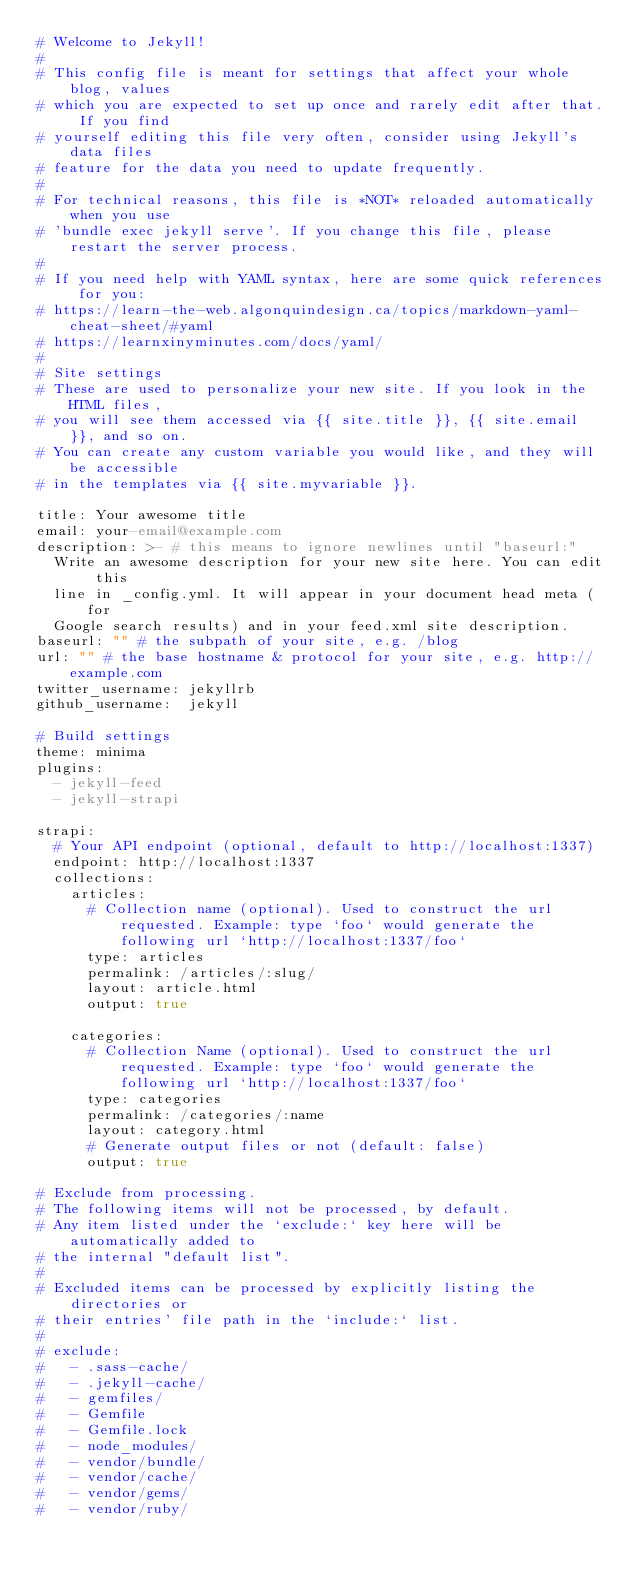<code> <loc_0><loc_0><loc_500><loc_500><_YAML_># Welcome to Jekyll!
#
# This config file is meant for settings that affect your whole blog, values
# which you are expected to set up once and rarely edit after that. If you find
# yourself editing this file very often, consider using Jekyll's data files
# feature for the data you need to update frequently.
#
# For technical reasons, this file is *NOT* reloaded automatically when you use
# 'bundle exec jekyll serve'. If you change this file, please restart the server process.
#
# If you need help with YAML syntax, here are some quick references for you: 
# https://learn-the-web.algonquindesign.ca/topics/markdown-yaml-cheat-sheet/#yaml
# https://learnxinyminutes.com/docs/yaml/
#
# Site settings
# These are used to personalize your new site. If you look in the HTML files,
# you will see them accessed via {{ site.title }}, {{ site.email }}, and so on.
# You can create any custom variable you would like, and they will be accessible
# in the templates via {{ site.myvariable }}.

title: Your awesome title
email: your-email@example.com
description: >- # this means to ignore newlines until "baseurl:"
  Write an awesome description for your new site here. You can edit this
  line in _config.yml. It will appear in your document head meta (for
  Google search results) and in your feed.xml site description.
baseurl: "" # the subpath of your site, e.g. /blog
url: "" # the base hostname & protocol for your site, e.g. http://example.com
twitter_username: jekyllrb
github_username:  jekyll

# Build settings
theme: minima
plugins:
  - jekyll-feed
  - jekyll-strapi

strapi:
  # Your API endpoint (optional, default to http://localhost:1337)
  endpoint: http://localhost:1337
  collections:
    articles:
      # Collection name (optional). Used to construct the url requested. Example: type `foo` would generate the following url `http://localhost:1337/foo`
      type: articles
      permalink: /articles/:slug/
      layout: article.html
      output: true

    categories:
      # Collection Name (optional). Used to construct the url requested. Example: type `foo` would generate the following url `http://localhost:1337/foo`
      type: categories
      permalink: /categories/:name
      layout: category.html
      # Generate output files or not (default: false)
      output: true

# Exclude from processing.
# The following items will not be processed, by default.
# Any item listed under the `exclude:` key here will be automatically added to
# the internal "default list".
#
# Excluded items can be processed by explicitly listing the directories or
# their entries' file path in the `include:` list.
#
# exclude:
#   - .sass-cache/
#   - .jekyll-cache/
#   - gemfiles/
#   - Gemfile
#   - Gemfile.lock
#   - node_modules/
#   - vendor/bundle/
#   - vendor/cache/
#   - vendor/gems/
#   - vendor/ruby/
</code> 